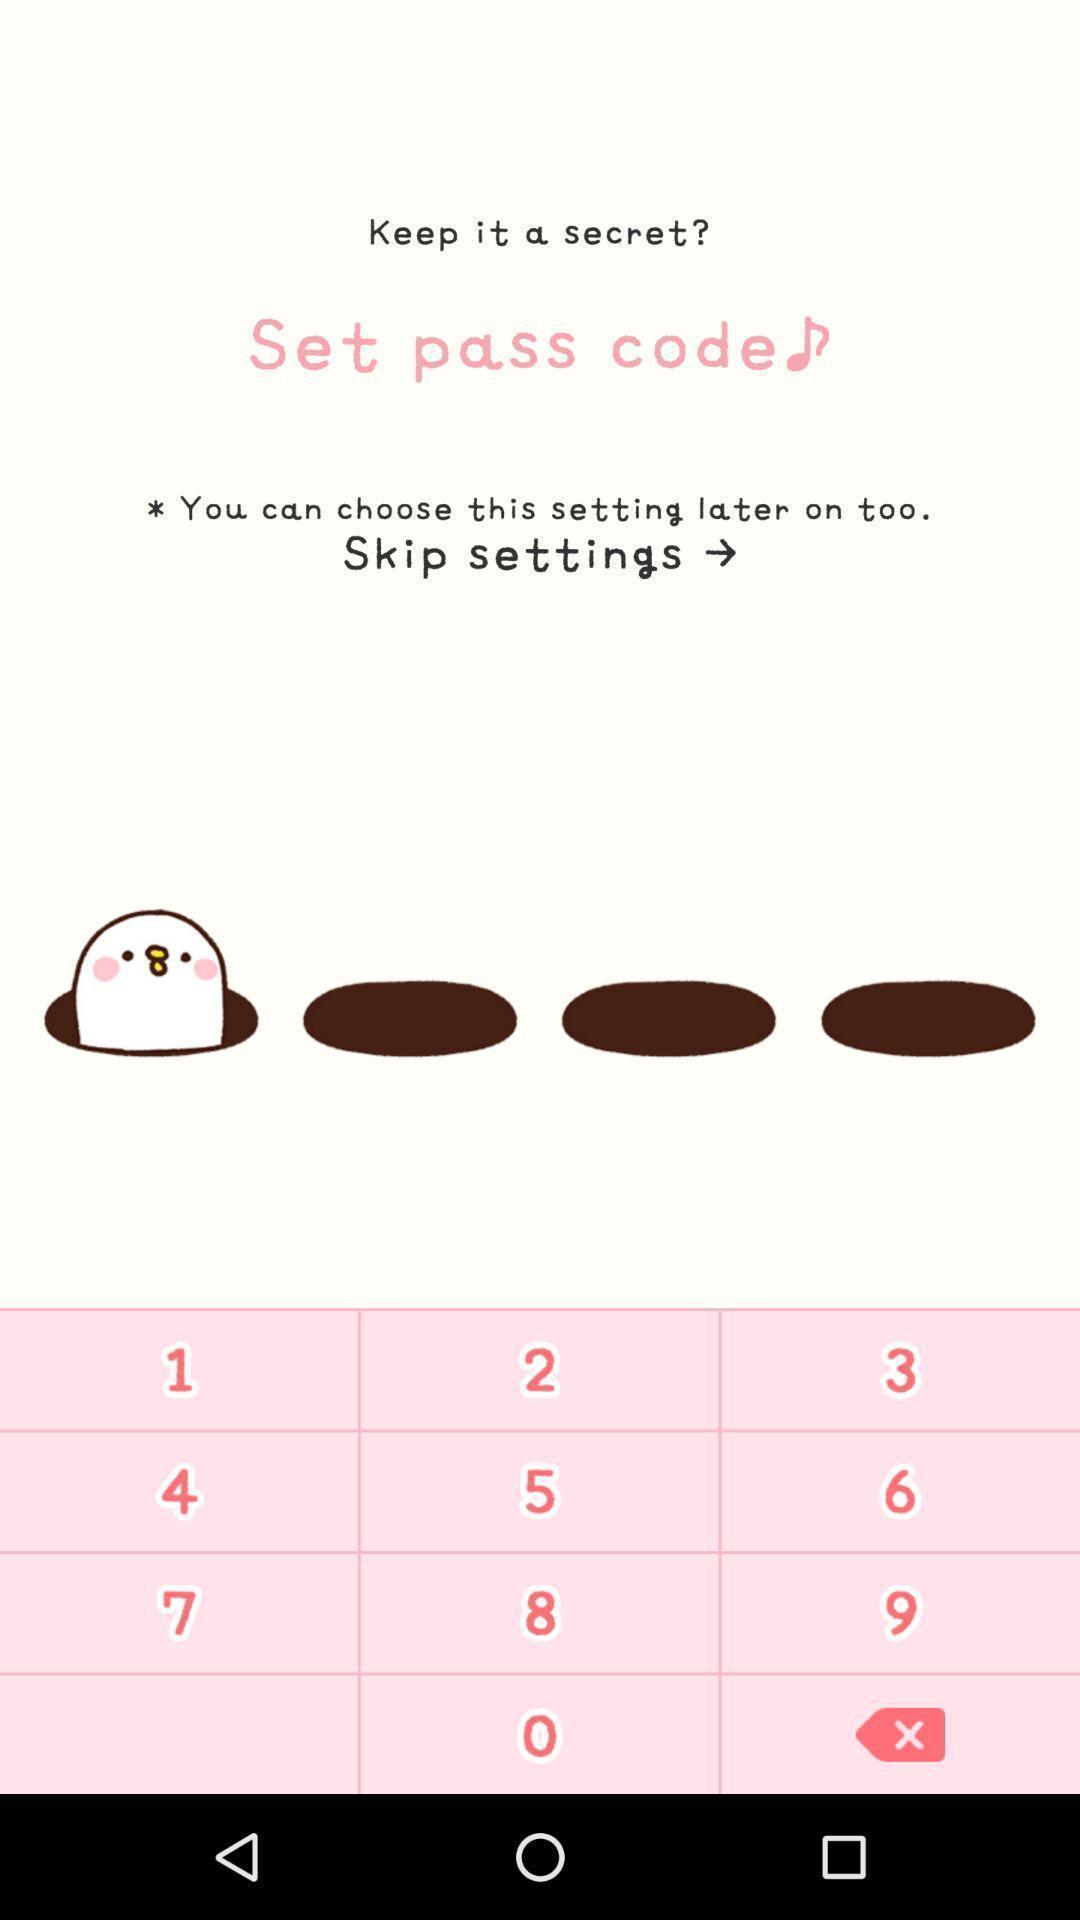Give me a narrative description of this picture. Screen displaying about the pin code. 